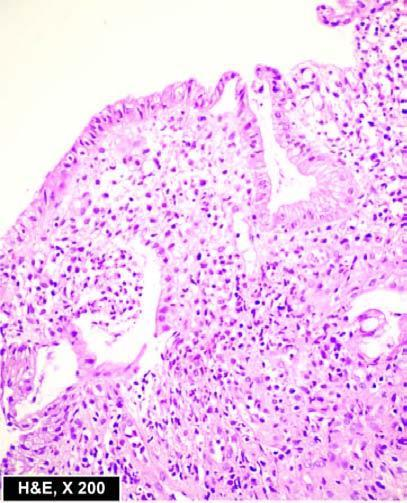re the microscopic features seen superficial ulcerations, with mucosal infiltration by inflammatory cells and a 'crypt abscess '?
Answer the question using a single word or phrase. Yes 